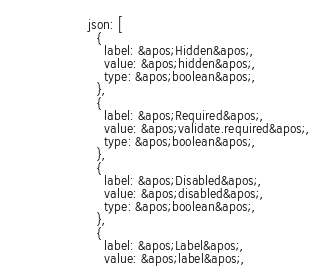Convert code to text. <code><loc_0><loc_0><loc_500><loc_500><_HTML_>                  json: [
                    {
                      label: &apos;Hidden&apos;,
                      value: &apos;hidden&apos;,
                      type: &apos;boolean&apos;,
                    },
                    {
                      label: &apos;Required&apos;,
                      value: &apos;validate.required&apos;,
                      type: &apos;boolean&apos;,
                    },
                    {
                      label: &apos;Disabled&apos;,
                      value: &apos;disabled&apos;,
                      type: &apos;boolean&apos;,
                    },
                    {
                      label: &apos;Label&apos;,
                      value: &apos;label&apos;,</code> 